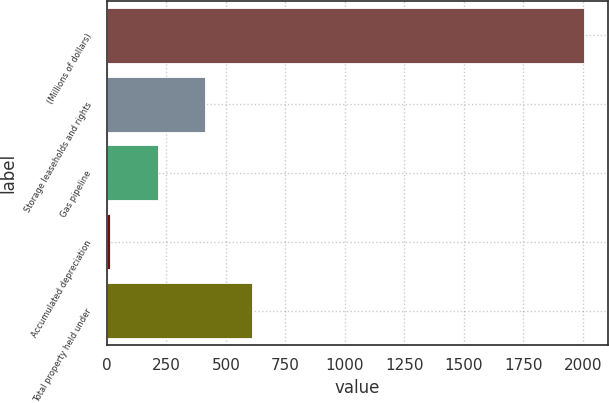<chart> <loc_0><loc_0><loc_500><loc_500><bar_chart><fcel>(Millions of dollars)<fcel>Storage leaseholds and rights<fcel>Gas pipeline<fcel>Accumulated depreciation<fcel>Total property held under<nl><fcel>2005<fcel>411.88<fcel>212.74<fcel>13.6<fcel>611.02<nl></chart> 